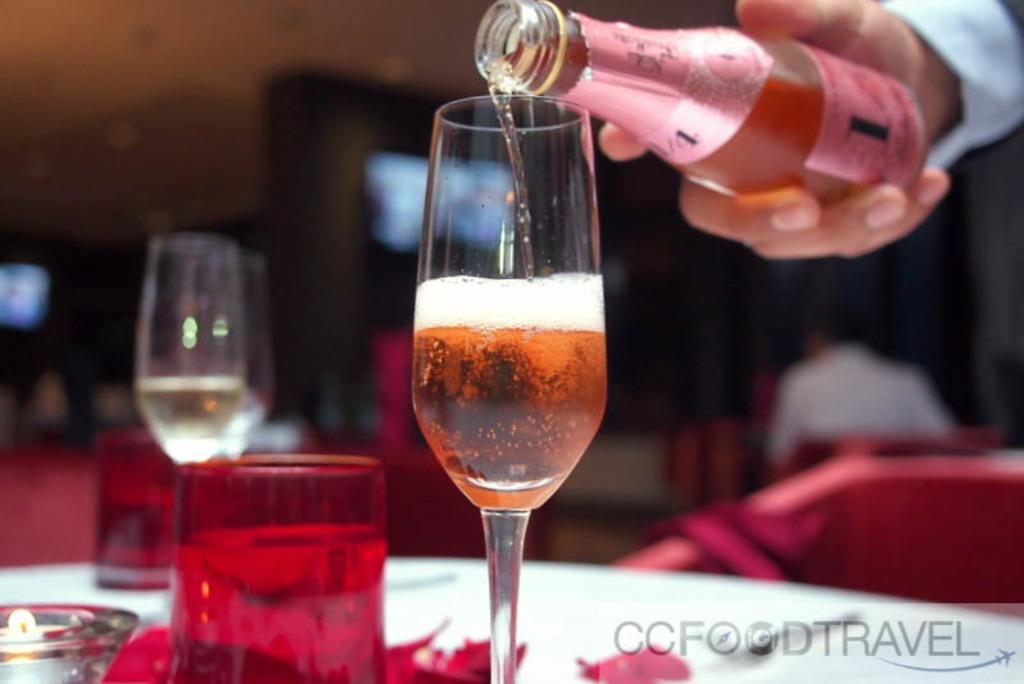Describe this image in one or two sentences. In this picture a man is holding a bottle and pouring the beer into the glass kept on the table, there is a table cover and a candle placed on the table. There is a person sitting and also a television. 